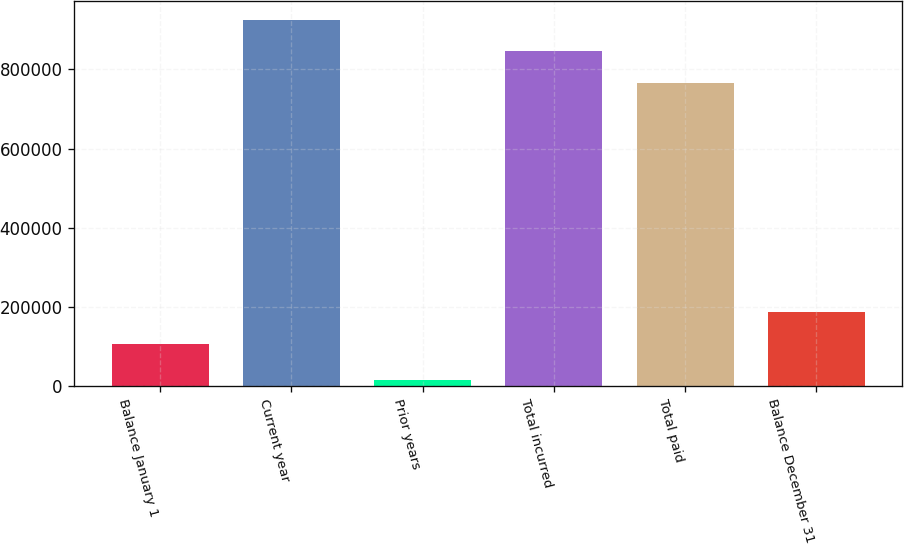<chart> <loc_0><loc_0><loc_500><loc_500><bar_chart><fcel>Balance January 1<fcel>Current year<fcel>Prior years<fcel>Total incurred<fcel>Total paid<fcel>Balance December 31<nl><fcel>106569<fcel>926069<fcel>15942<fcel>846022<fcel>765974<fcel>186617<nl></chart> 